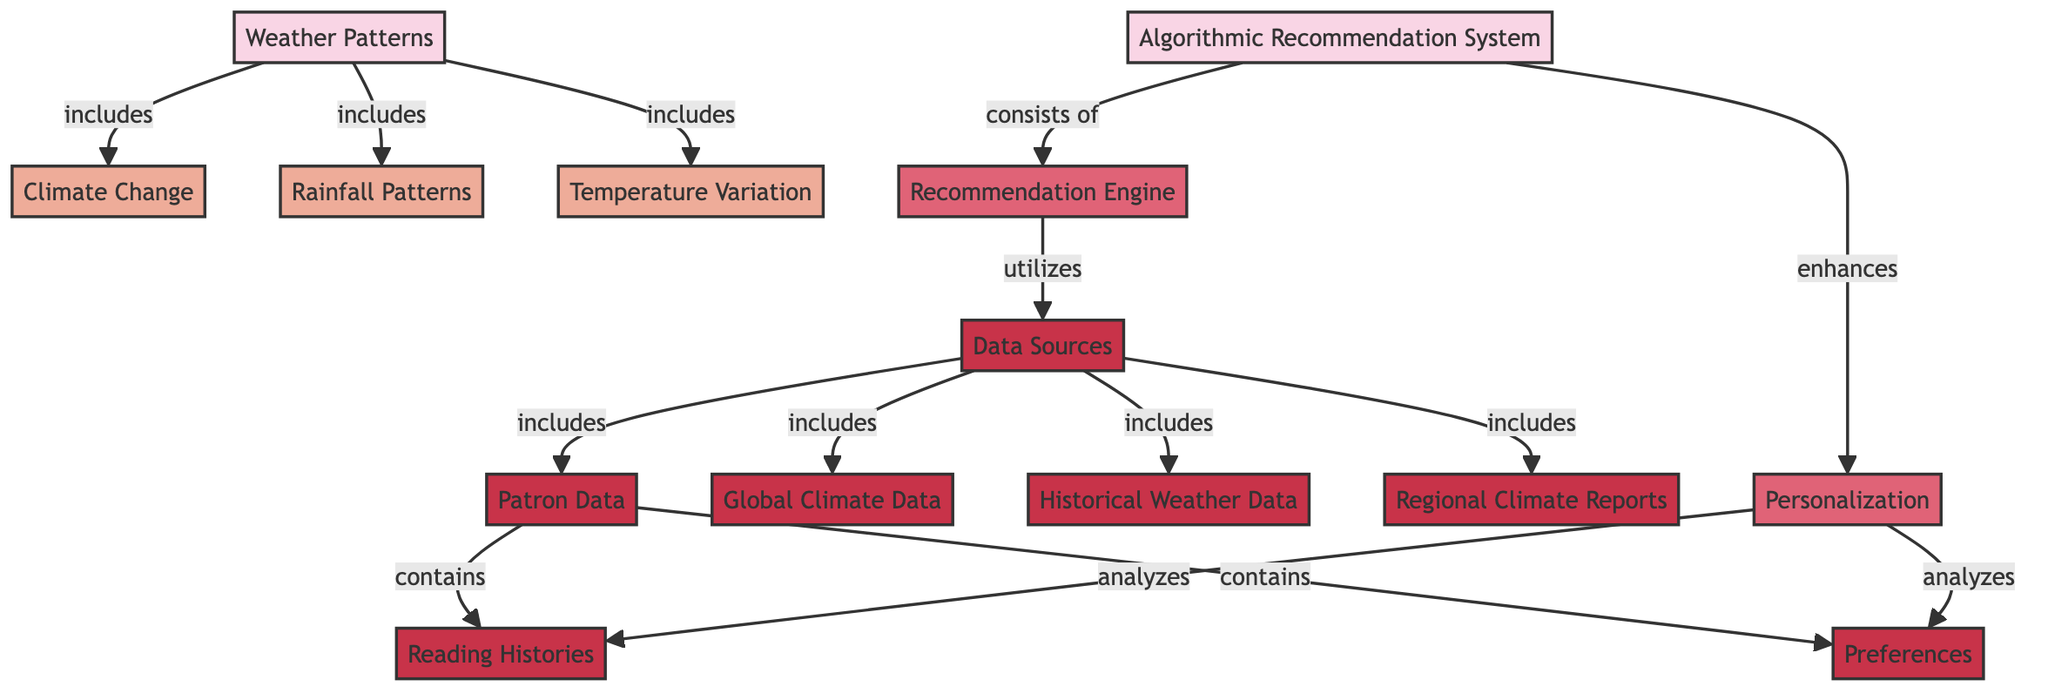What are the three main types of weather patterns included in the diagram? The diagram includes three main types of weather patterns: climate change, rainfall patterns, and temperature variation, represented as nodes branching from the "Weather Patterns" category.
Answer: climate change, rainfall patterns, temperature variation How many data sources are utilized in the algorithmic recommendation system? The diagram outlines that there are five data sources utilized by the recommendation engine within the algorithmic recommendation system: global climate data, historical weather data, regional climate reports, patron data, and preferences.
Answer: 5 What component enhances personalization in the diagram? The diagram shows that the recommendation engine is the component that enhances personalization. This is highlighted by the direct link from the algorithmic recommendation system to personalization.
Answer: recommendation engine Which data source contains reading histories? According to the diagram, reading histories are contained within patron data, which is a sub-node under data sources.
Answer: patron data What are the two types of information that personalization analyzes? The diagram indicates that personalization analyzes two types of information: reading histories and preferences, both connected under patron data.
Answer: reading histories, preferences What category does rainfall patterns belong to? The diagram classifies rainfall patterns under the "Weather Patterns" category, showing its direct link as a subcategory of this main category.
Answer: Weather Patterns Which two components are included in the algorithmic recommendation system? The diagram specifies that the algorithmic recommendation system consists of two components: the recommendation engine and personalization, indicated by connections leading to both nodes.
Answer: recommendation engine, personalization How does the recommendation engine utilize data sources? The recommendation engine utilizes data sources through a direct relation shown in the diagram, highlighting that it pulls information from various sources for generating recommendations.
Answer: utilizes data sources What is the relationship between patron data and preferences? The diagram shows that patron data contains preferences, illustrating a hierarchical structure where preferences are a subset of patron data.
Answer: contains 